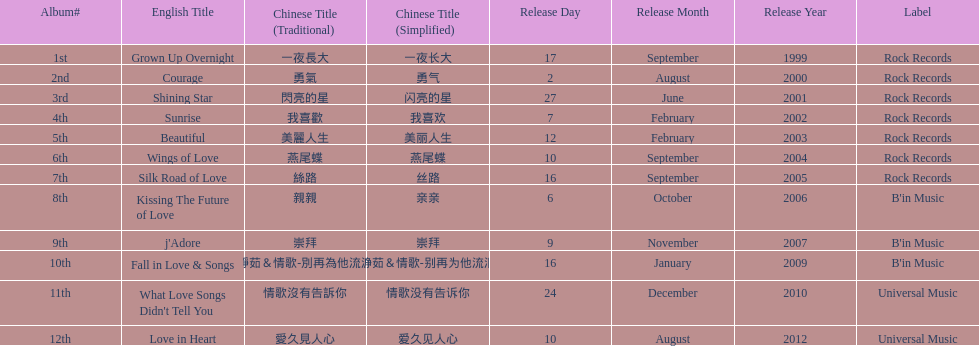Would you mind parsing the complete table? {'header': ['Album#', 'English Title', 'Chinese Title (Traditional)', 'Chinese Title (Simplified)', 'Release Day', 'Release Month', 'Release Year', 'Label'], 'rows': [['1st', 'Grown Up Overnight', '一夜長大', '一夜长大', '17', 'September', '1999', 'Rock Records'], ['2nd', 'Courage', '勇氣', '勇气', '2', 'August', '2000', 'Rock Records'], ['3rd', 'Shining Star', '閃亮的星', '闪亮的星', '27', 'June', '2001', 'Rock Records'], ['4th', 'Sunrise', '我喜歡', '我喜欢', '7', 'February', '2002', 'Rock Records'], ['5th', 'Beautiful', '美麗人生', '美丽人生', '12', 'February', '2003', 'Rock Records'], ['6th', 'Wings of Love', '燕尾蝶', '燕尾蝶', '10', 'September', '2004', 'Rock Records'], ['7th', 'Silk Road of Love', '絲路', '丝路', '16', 'September', '2005', 'Rock Records'], ['8th', 'Kissing The Future of Love', '親親', '亲亲', '6', 'October', '2006', "B'in Music"], ['9th', "j'Adore", '崇拜', '崇拜', '9', 'November', '2007', "B'in Music"], ['10th', 'Fall in Love & Songs', '靜茹＆情歌-別再為他流淚', '静茹＆情歌-别再为他流泪', '16', 'January', '2009', "B'in Music"], ['11th', "What Love Songs Didn't Tell You", '情歌沒有告訴你', '情歌没有告诉你', '24', 'December', '2010', 'Universal Music'], ['12th', 'Love in Heart', '愛久見人心', '爱久见人心', '10', 'August', '2012', 'Universal Music']]} Which album was released later, beautiful, or j'adore? J'adore. 